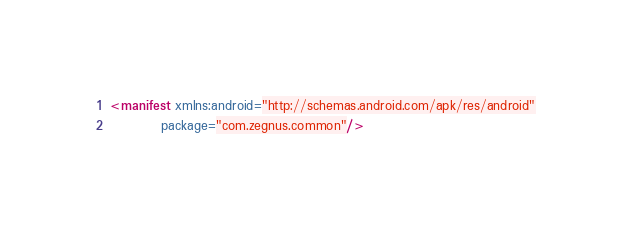Convert code to text. <code><loc_0><loc_0><loc_500><loc_500><_XML_><manifest xmlns:android="http://schemas.android.com/apk/res/android"
          package="com.zegnus.common"/>
</code> 